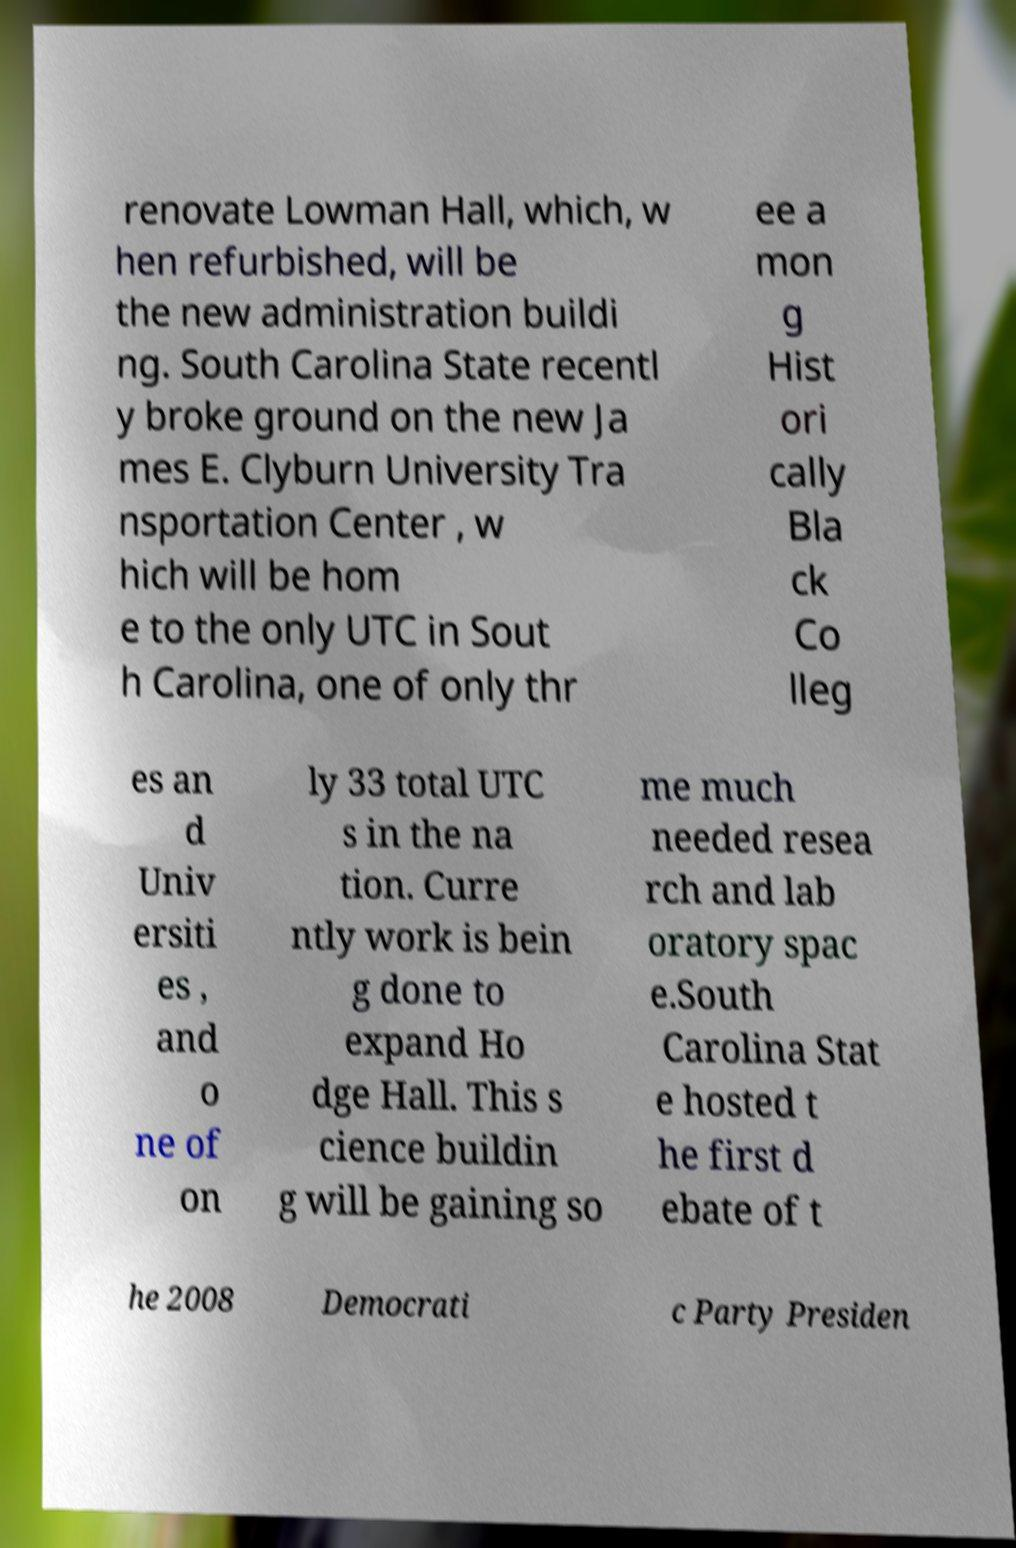Could you extract and type out the text from this image? renovate Lowman Hall, which, w hen refurbished, will be the new administration buildi ng. South Carolina State recentl y broke ground on the new Ja mes E. Clyburn University Tra nsportation Center , w hich will be hom e to the only UTC in Sout h Carolina, one of only thr ee a mon g Hist ori cally Bla ck Co lleg es an d Univ ersiti es , and o ne of on ly 33 total UTC s in the na tion. Curre ntly work is bein g done to expand Ho dge Hall. This s cience buildin g will be gaining so me much needed resea rch and lab oratory spac e.South Carolina Stat e hosted t he first d ebate of t he 2008 Democrati c Party Presiden 